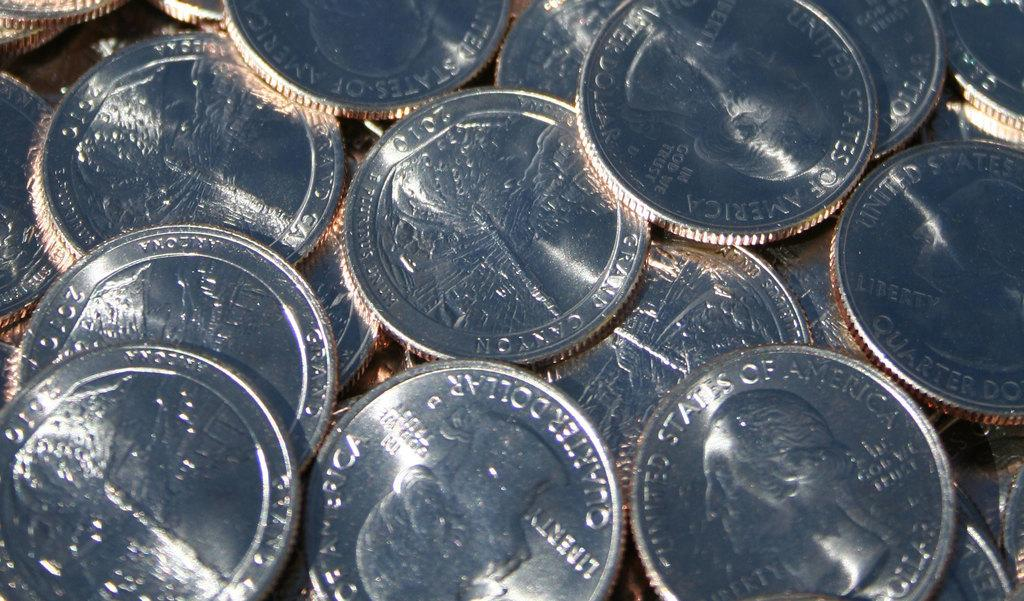<image>
Offer a succinct explanation of the picture presented. A collection of several coins, some saying United States of America on them. 